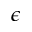Convert formula to latex. <formula><loc_0><loc_0><loc_500><loc_500>\epsilon</formula> 